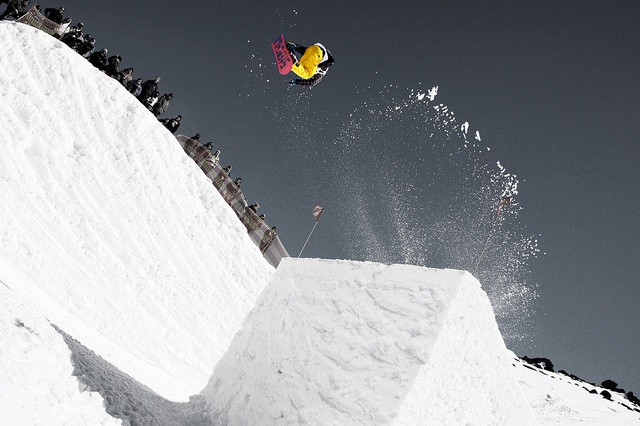Describe the objects in this image and their specific colors. I can see people in black, orange, gold, and yellow tones, snowboard in black, purple, brown, and navy tones, people in black, gray, and darkgray tones, people in black, gray, and darkgray tones, and people in black, gray, and darkgray tones in this image. 